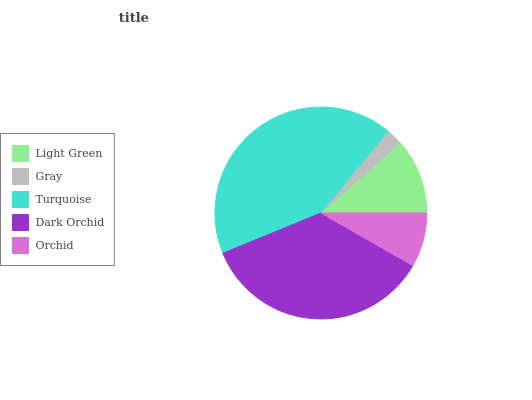Is Gray the minimum?
Answer yes or no. Yes. Is Turquoise the maximum?
Answer yes or no. Yes. Is Turquoise the minimum?
Answer yes or no. No. Is Gray the maximum?
Answer yes or no. No. Is Turquoise greater than Gray?
Answer yes or no. Yes. Is Gray less than Turquoise?
Answer yes or no. Yes. Is Gray greater than Turquoise?
Answer yes or no. No. Is Turquoise less than Gray?
Answer yes or no. No. Is Light Green the high median?
Answer yes or no. Yes. Is Light Green the low median?
Answer yes or no. Yes. Is Dark Orchid the high median?
Answer yes or no. No. Is Turquoise the low median?
Answer yes or no. No. 